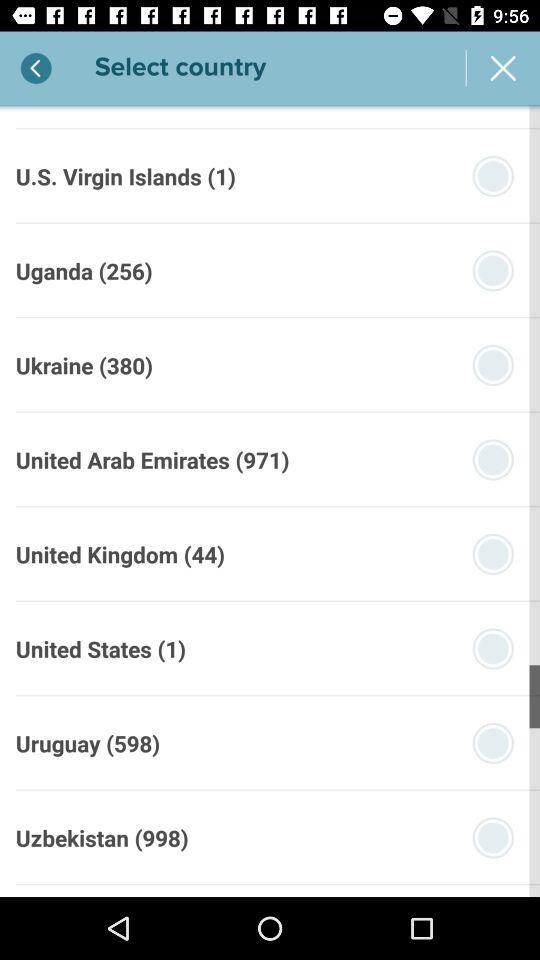What is the code of Uganda? The country code of Uganda is 256. 